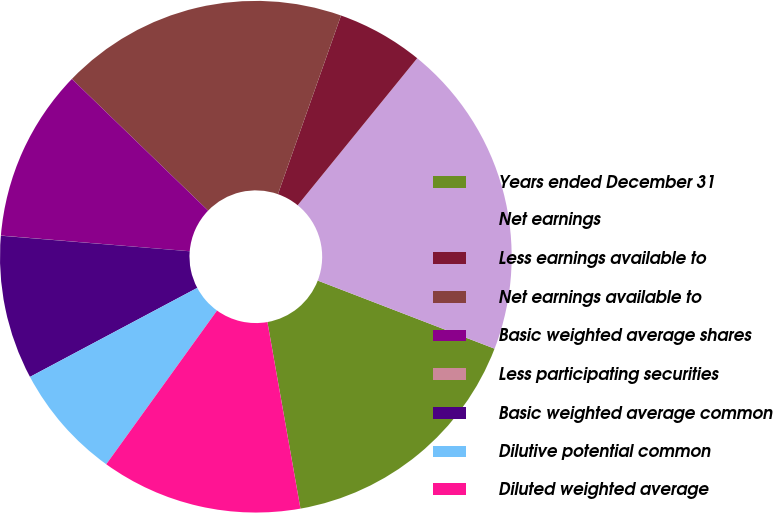<chart> <loc_0><loc_0><loc_500><loc_500><pie_chart><fcel>Years ended December 31<fcel>Net earnings<fcel>Less earnings available to<fcel>Net earnings available to<fcel>Basic weighted average shares<fcel>Less participating securities<fcel>Basic weighted average common<fcel>Dilutive potential common<fcel>Diluted weighted average<nl><fcel>16.36%<fcel>19.99%<fcel>5.46%<fcel>18.18%<fcel>10.91%<fcel>0.01%<fcel>9.09%<fcel>7.28%<fcel>12.73%<nl></chart> 